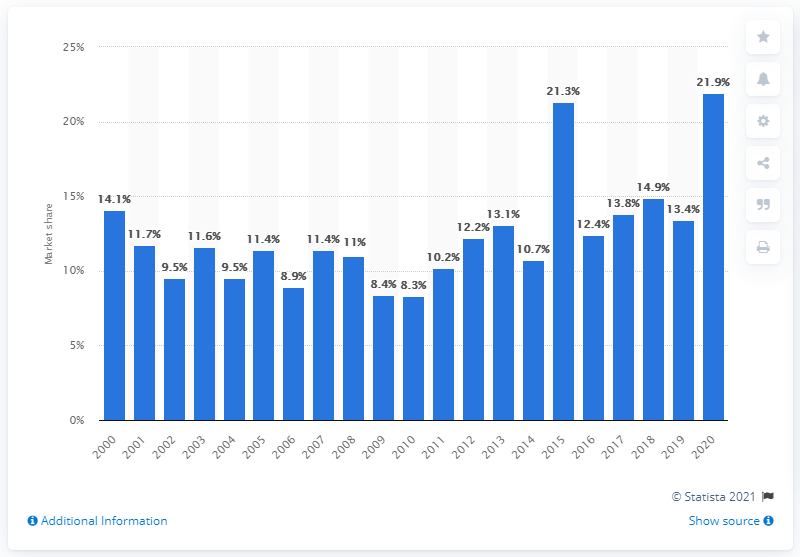Give some essential details in this illustration. Universal releases accounted for 21.9% of all earnings at the box office in North America in 2020. 